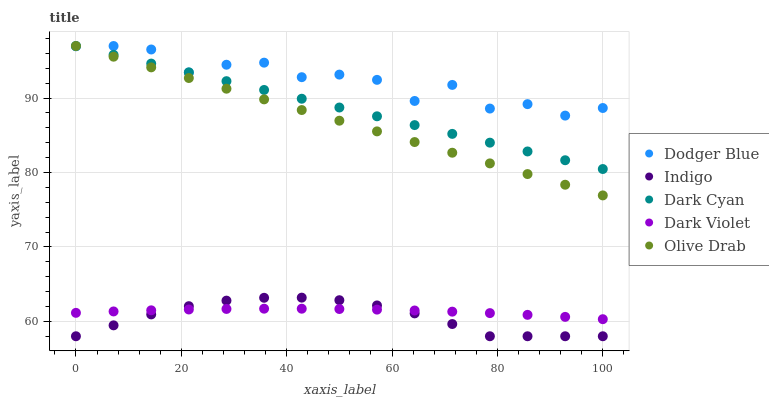Does Indigo have the minimum area under the curve?
Answer yes or no. Yes. Does Dodger Blue have the maximum area under the curve?
Answer yes or no. Yes. Does Dodger Blue have the minimum area under the curve?
Answer yes or no. No. Does Indigo have the maximum area under the curve?
Answer yes or no. No. Is Olive Drab the smoothest?
Answer yes or no. Yes. Is Dodger Blue the roughest?
Answer yes or no. Yes. Is Indigo the smoothest?
Answer yes or no. No. Is Indigo the roughest?
Answer yes or no. No. Does Indigo have the lowest value?
Answer yes or no. Yes. Does Dodger Blue have the lowest value?
Answer yes or no. No. Does Olive Drab have the highest value?
Answer yes or no. Yes. Does Indigo have the highest value?
Answer yes or no. No. Is Indigo less than Dodger Blue?
Answer yes or no. Yes. Is Dark Cyan greater than Dark Violet?
Answer yes or no. Yes. Does Dodger Blue intersect Dark Cyan?
Answer yes or no. Yes. Is Dodger Blue less than Dark Cyan?
Answer yes or no. No. Is Dodger Blue greater than Dark Cyan?
Answer yes or no. No. Does Indigo intersect Dodger Blue?
Answer yes or no. No. 